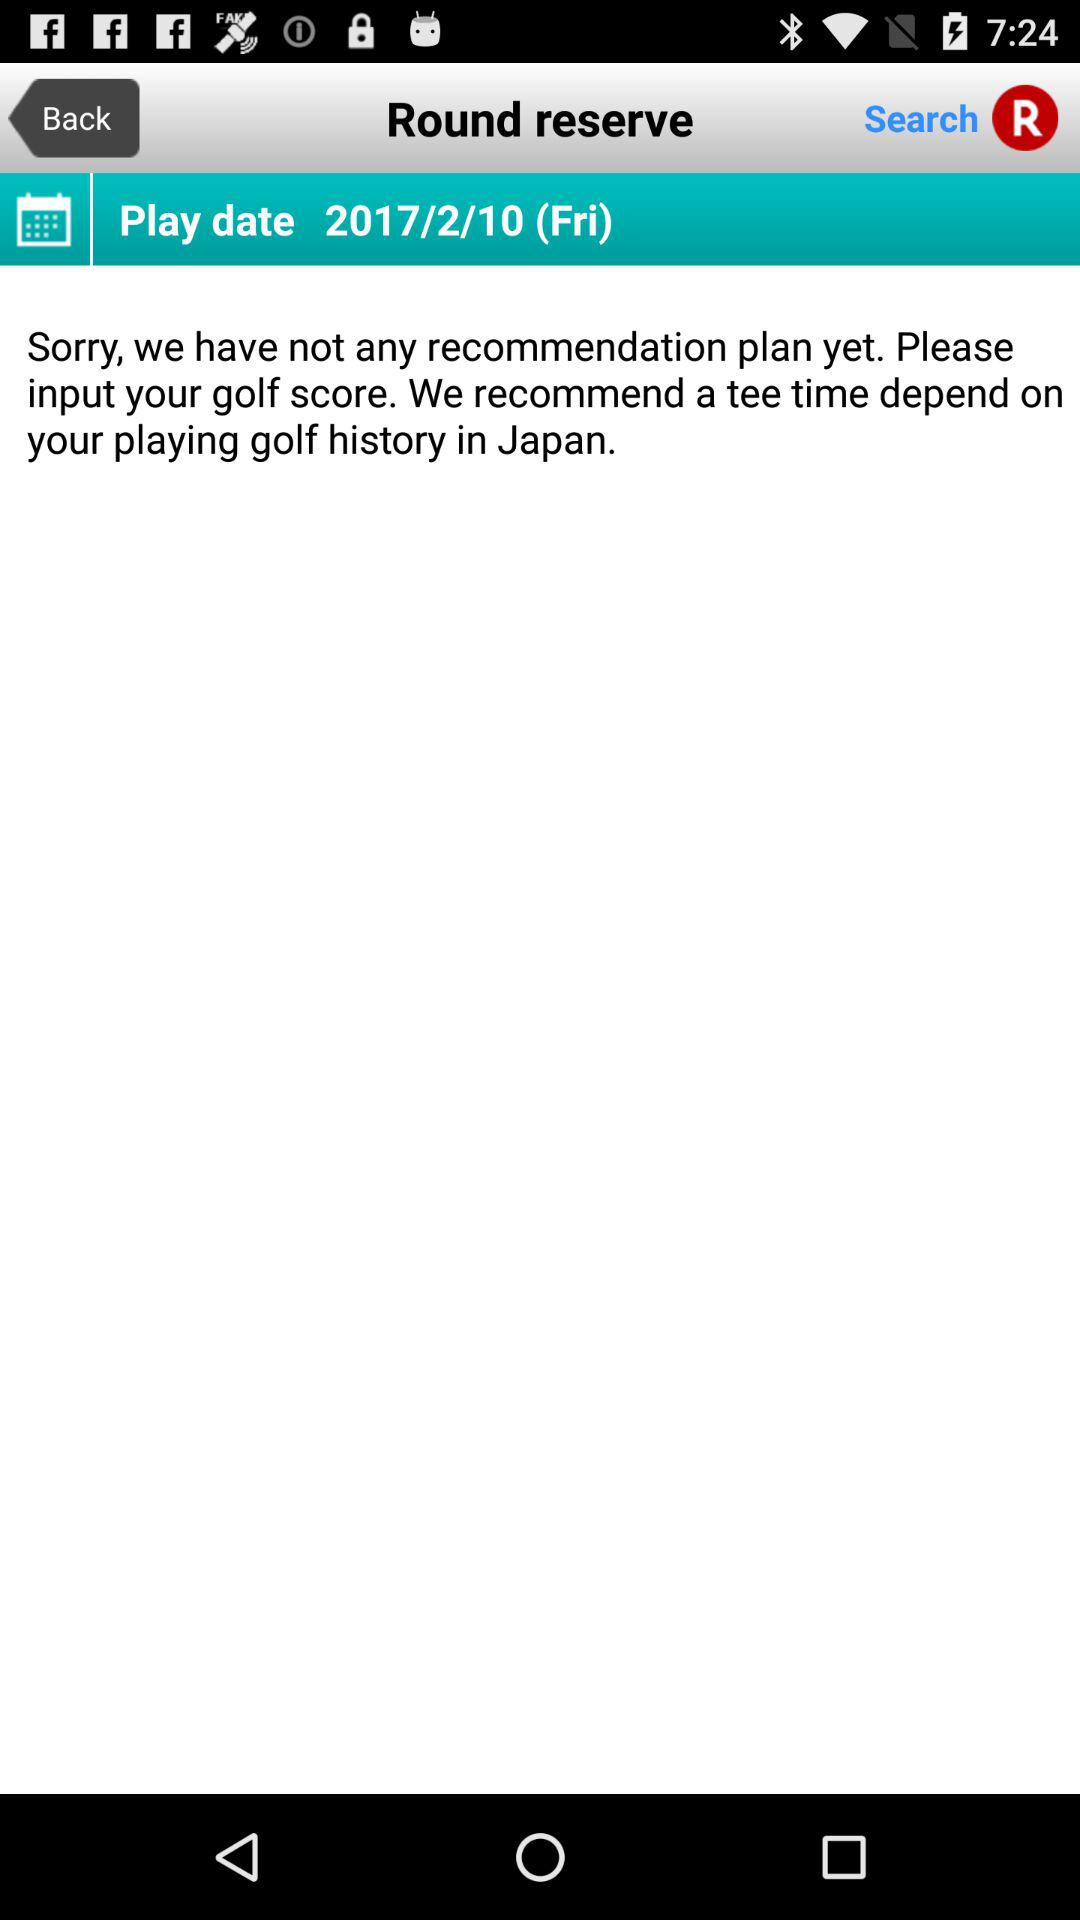What is the day? The day is Friday. 